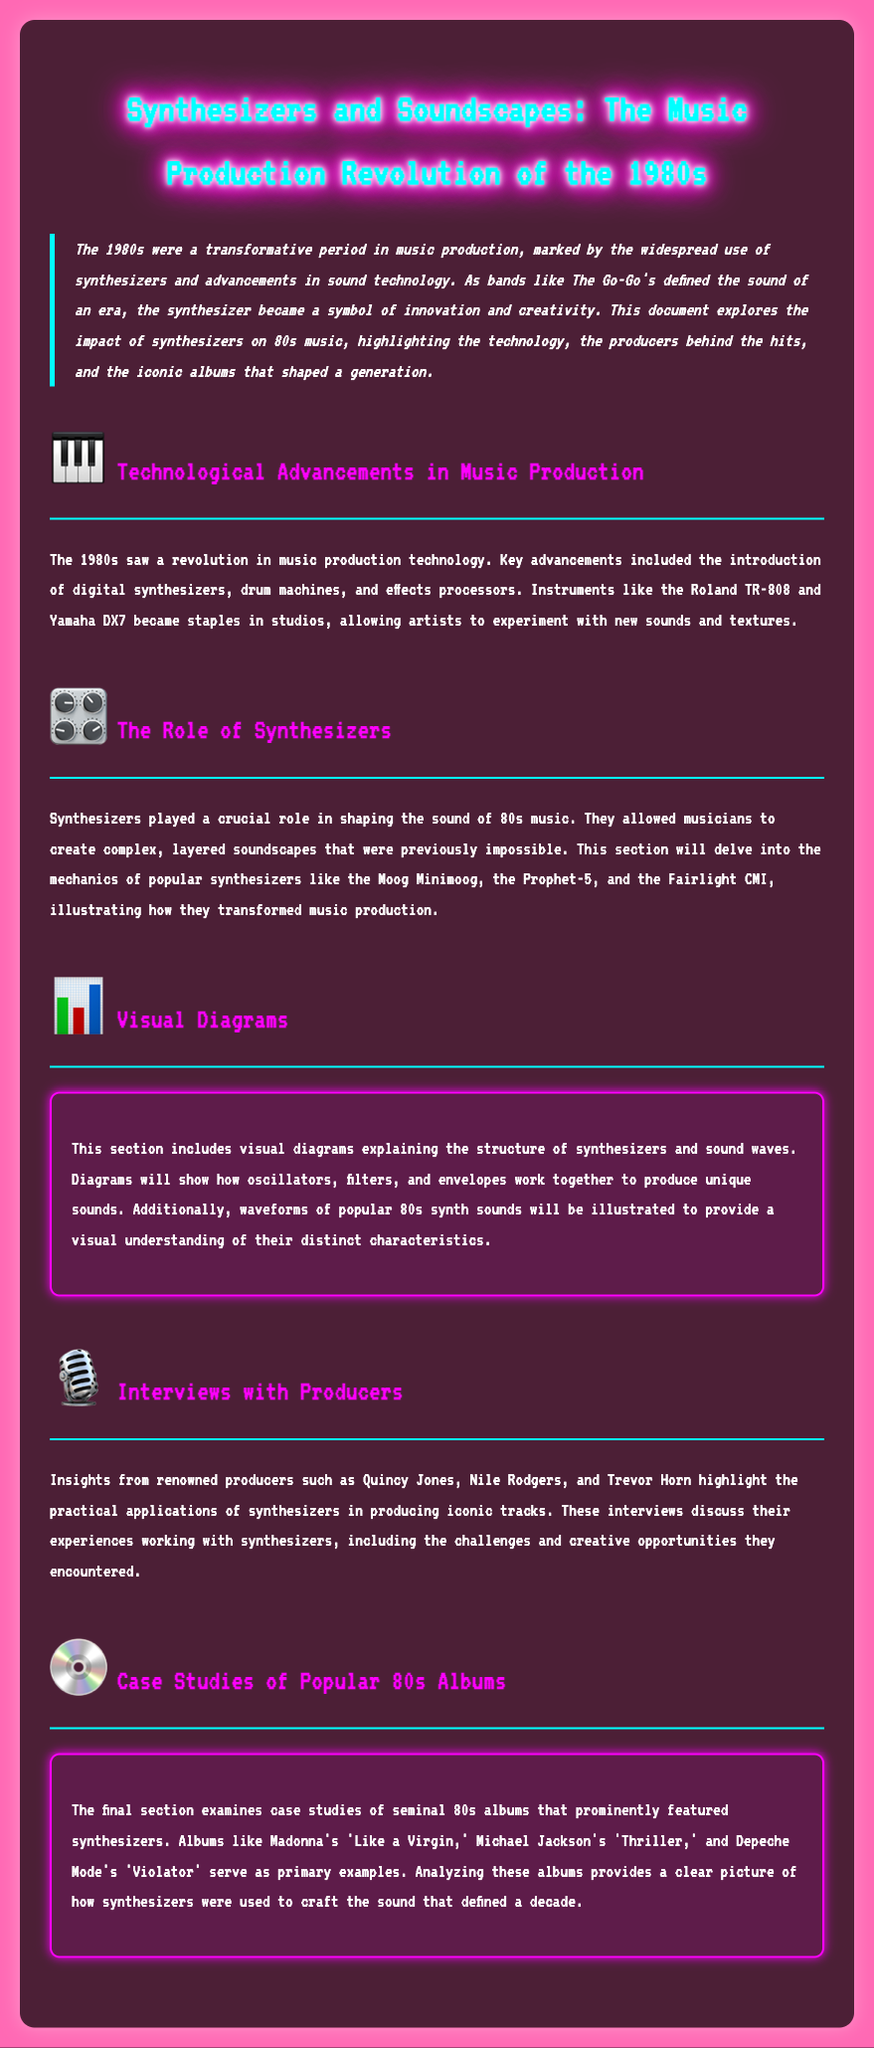What instrument became a staple in studios during the 1980s? The document mentions the Roland TR-808 and Yamaha DX7 as key instruments that revolutionized music production.
Answer: Roland TR-808 Which section discusses visual diagrams? The section titled "Visual Diagrams" specifically mentions diagrams related to sound waves and synthesizer components.
Answer: Visual Diagrams Who were some renowned producers interviewed in the document? The document lists Quincy Jones, Nile Rodgers, and Trevor Horn as producers providing insights.
Answer: Quincy Jones, Nile Rodgers, Trevor Horn What iconic album is mentioned as a case study? The document references several albums, including Madonna's "Like a Virgin," as a prominent example of 80s music featuring synthesizers.
Answer: Like a Virgin What was a key advancement in music production technology in the 1980s? The section on technological advancements highlights the introduction of digital synthesizers as a pivotal moment in music production.
Answer: Digital synthesizers 